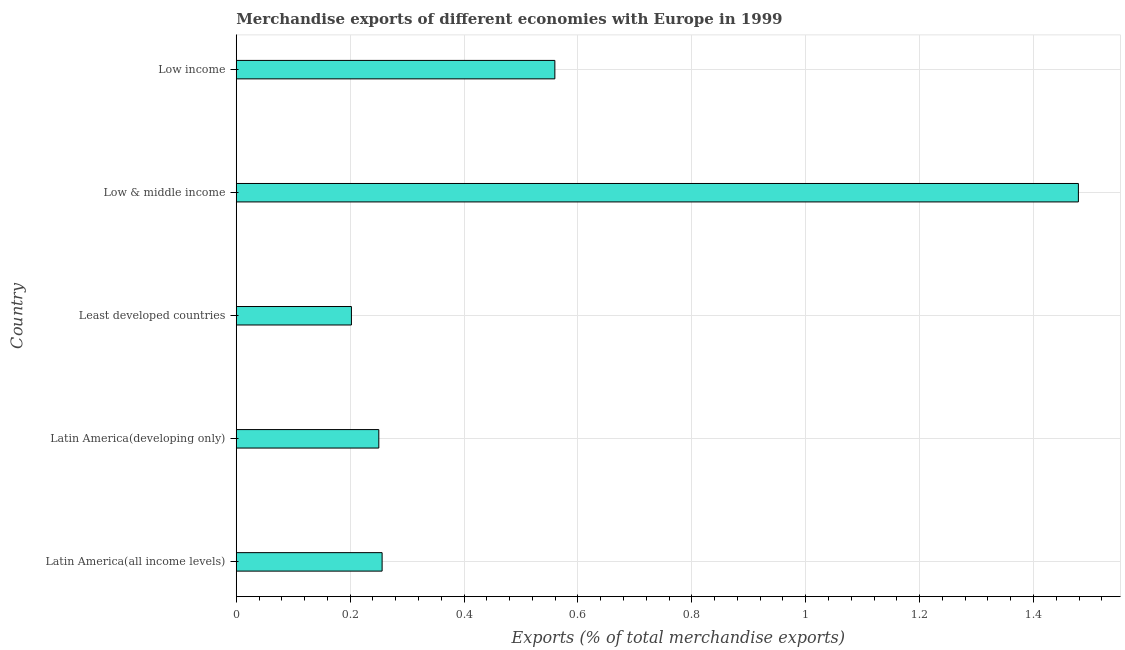Does the graph contain any zero values?
Provide a succinct answer. No. What is the title of the graph?
Make the answer very short. Merchandise exports of different economies with Europe in 1999. What is the label or title of the X-axis?
Ensure brevity in your answer.  Exports (% of total merchandise exports). What is the label or title of the Y-axis?
Give a very brief answer. Country. What is the merchandise exports in Latin America(developing only)?
Your response must be concise. 0.25. Across all countries, what is the maximum merchandise exports?
Your response must be concise. 1.48. Across all countries, what is the minimum merchandise exports?
Keep it short and to the point. 0.2. In which country was the merchandise exports minimum?
Provide a succinct answer. Least developed countries. What is the sum of the merchandise exports?
Make the answer very short. 2.75. What is the difference between the merchandise exports in Latin America(developing only) and Low income?
Offer a terse response. -0.31. What is the average merchandise exports per country?
Your answer should be very brief. 0.55. What is the median merchandise exports?
Make the answer very short. 0.26. In how many countries, is the merchandise exports greater than 0.92 %?
Your response must be concise. 1. What is the ratio of the merchandise exports in Latin America(developing only) to that in Low income?
Give a very brief answer. 0.45. Is the merchandise exports in Latin America(all income levels) less than that in Low & middle income?
Offer a terse response. Yes. Is the difference between the merchandise exports in Latin America(all income levels) and Low & middle income greater than the difference between any two countries?
Provide a succinct answer. No. What is the difference between the highest and the second highest merchandise exports?
Give a very brief answer. 0.92. Is the sum of the merchandise exports in Latin America(all income levels) and Least developed countries greater than the maximum merchandise exports across all countries?
Make the answer very short. No. What is the difference between the highest and the lowest merchandise exports?
Provide a short and direct response. 1.28. In how many countries, is the merchandise exports greater than the average merchandise exports taken over all countries?
Provide a succinct answer. 2. How many bars are there?
Offer a terse response. 5. How many countries are there in the graph?
Give a very brief answer. 5. What is the difference between two consecutive major ticks on the X-axis?
Your response must be concise. 0.2. Are the values on the major ticks of X-axis written in scientific E-notation?
Provide a succinct answer. No. What is the Exports (% of total merchandise exports) in Latin America(all income levels)?
Make the answer very short. 0.26. What is the Exports (% of total merchandise exports) of Latin America(developing only)?
Your response must be concise. 0.25. What is the Exports (% of total merchandise exports) of Least developed countries?
Provide a succinct answer. 0.2. What is the Exports (% of total merchandise exports) in Low & middle income?
Your answer should be very brief. 1.48. What is the Exports (% of total merchandise exports) of Low income?
Offer a terse response. 0.56. What is the difference between the Exports (% of total merchandise exports) in Latin America(all income levels) and Latin America(developing only)?
Your response must be concise. 0.01. What is the difference between the Exports (% of total merchandise exports) in Latin America(all income levels) and Least developed countries?
Your answer should be very brief. 0.05. What is the difference between the Exports (% of total merchandise exports) in Latin America(all income levels) and Low & middle income?
Provide a succinct answer. -1.22. What is the difference between the Exports (% of total merchandise exports) in Latin America(all income levels) and Low income?
Offer a very short reply. -0.3. What is the difference between the Exports (% of total merchandise exports) in Latin America(developing only) and Least developed countries?
Offer a very short reply. 0.05. What is the difference between the Exports (% of total merchandise exports) in Latin America(developing only) and Low & middle income?
Make the answer very short. -1.23. What is the difference between the Exports (% of total merchandise exports) in Latin America(developing only) and Low income?
Your answer should be very brief. -0.31. What is the difference between the Exports (% of total merchandise exports) in Least developed countries and Low & middle income?
Offer a very short reply. -1.28. What is the difference between the Exports (% of total merchandise exports) in Least developed countries and Low income?
Ensure brevity in your answer.  -0.36. What is the difference between the Exports (% of total merchandise exports) in Low & middle income and Low income?
Provide a short and direct response. 0.92. What is the ratio of the Exports (% of total merchandise exports) in Latin America(all income levels) to that in Latin America(developing only)?
Your answer should be compact. 1.02. What is the ratio of the Exports (% of total merchandise exports) in Latin America(all income levels) to that in Least developed countries?
Offer a very short reply. 1.27. What is the ratio of the Exports (% of total merchandise exports) in Latin America(all income levels) to that in Low & middle income?
Offer a very short reply. 0.17. What is the ratio of the Exports (% of total merchandise exports) in Latin America(all income levels) to that in Low income?
Your response must be concise. 0.46. What is the ratio of the Exports (% of total merchandise exports) in Latin America(developing only) to that in Least developed countries?
Your response must be concise. 1.24. What is the ratio of the Exports (% of total merchandise exports) in Latin America(developing only) to that in Low & middle income?
Provide a short and direct response. 0.17. What is the ratio of the Exports (% of total merchandise exports) in Latin America(developing only) to that in Low income?
Keep it short and to the point. 0.45. What is the ratio of the Exports (% of total merchandise exports) in Least developed countries to that in Low & middle income?
Offer a terse response. 0.14. What is the ratio of the Exports (% of total merchandise exports) in Least developed countries to that in Low income?
Offer a terse response. 0.36. What is the ratio of the Exports (% of total merchandise exports) in Low & middle income to that in Low income?
Ensure brevity in your answer.  2.64. 